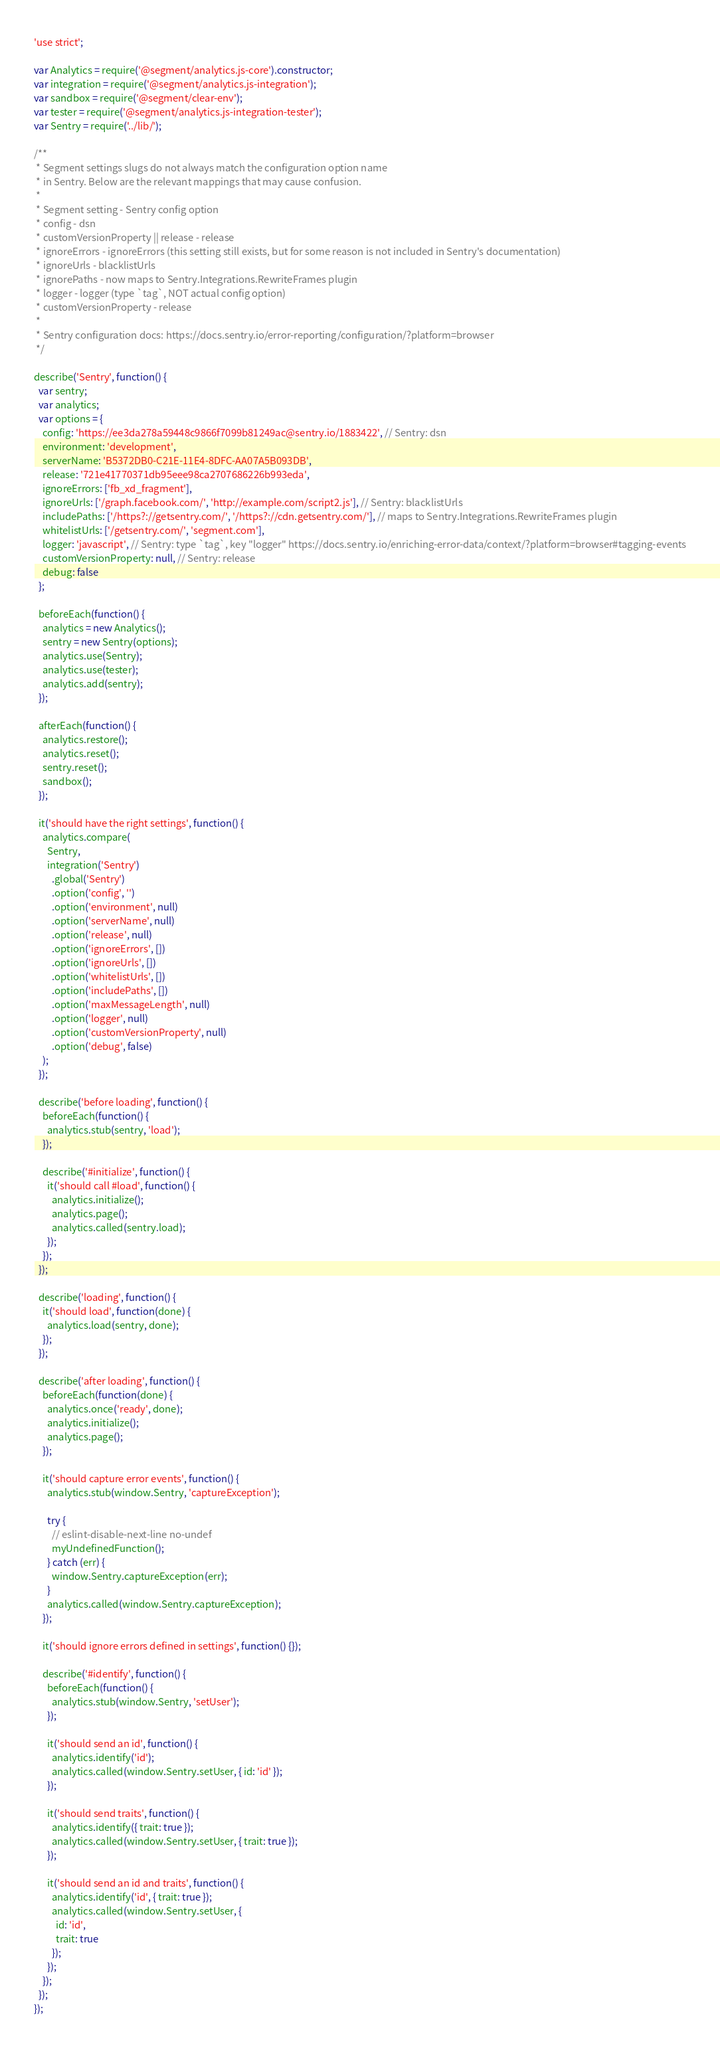<code> <loc_0><loc_0><loc_500><loc_500><_JavaScript_>'use strict';

var Analytics = require('@segment/analytics.js-core').constructor;
var integration = require('@segment/analytics.js-integration');
var sandbox = require('@segment/clear-env');
var tester = require('@segment/analytics.js-integration-tester');
var Sentry = require('../lib/');

/**
 * Segment settings slugs do not always match the configuration option name
 * in Sentry. Below are the relevant mappings that may cause confusion.
 *
 * Segment setting - Sentry config option
 * config - dsn
 * customVersionProperty || release - release
 * ignoreErrors - ignoreErrors (this setting still exists, but for some reason is not included in Sentry's documentation)
 * ignoreUrls - blacklistUrls
 * ignorePaths - now maps to Sentry.Integrations.RewriteFrames plugin
 * logger - logger (type `tag`, NOT actual config option)
 * customVersionProperty - release
 *
 * Sentry configuration docs: https://docs.sentry.io/error-reporting/configuration/?platform=browser
 */

describe('Sentry', function() {
  var sentry;
  var analytics;
  var options = {
    config: 'https://ee3da278a59448c9866f7099b81249ac@sentry.io/1883422', // Sentry: dsn
    environment: 'development',
    serverName: 'B5372DB0-C21E-11E4-8DFC-AA07A5B093DB',
    release: '721e41770371db95eee98ca2707686226b993eda',
    ignoreErrors: ['fb_xd_fragment'],
    ignoreUrls: ['/graph.facebook.com/', 'http://example.com/script2.js'], // Sentry: blacklistUrls
    includePaths: ['/https?://getsentry.com/', '/https?://cdn.getsentry.com/'], // maps to Sentry.Integrations.RewriteFrames plugin
    whitelistUrls: ['/getsentry.com/', 'segment.com'],
    logger: 'javascript', // Sentry: type `tag`, key "logger" https://docs.sentry.io/enriching-error-data/context/?platform=browser#tagging-events
    customVersionProperty: null, // Sentry: release
    debug: false
  };

  beforeEach(function() {
    analytics = new Analytics();
    sentry = new Sentry(options);
    analytics.use(Sentry);
    analytics.use(tester);
    analytics.add(sentry);
  });

  afterEach(function() {
    analytics.restore();
    analytics.reset();
    sentry.reset();
    sandbox();
  });

  it('should have the right settings', function() {
    analytics.compare(
      Sentry,
      integration('Sentry')
        .global('Sentry')
        .option('config', '')
        .option('environment', null)
        .option('serverName', null)
        .option('release', null)
        .option('ignoreErrors', [])
        .option('ignoreUrls', [])
        .option('whitelistUrls', [])
        .option('includePaths', [])
        .option('maxMessageLength', null)
        .option('logger', null)
        .option('customVersionProperty', null)
        .option('debug', false)
    );
  });

  describe('before loading', function() {
    beforeEach(function() {
      analytics.stub(sentry, 'load');
    });

    describe('#initialize', function() {
      it('should call #load', function() {
        analytics.initialize();
        analytics.page();
        analytics.called(sentry.load);
      });
    });
  });

  describe('loading', function() {
    it('should load', function(done) {
      analytics.load(sentry, done);
    });
  });

  describe('after loading', function() {
    beforeEach(function(done) {
      analytics.once('ready', done);
      analytics.initialize();
      analytics.page();
    });

    it('should capture error events', function() {
      analytics.stub(window.Sentry, 'captureException');

      try {
        // eslint-disable-next-line no-undef
        myUndefinedFunction();
      } catch (err) {
        window.Sentry.captureException(err);
      }
      analytics.called(window.Sentry.captureException);
    });

    it('should ignore errors defined in settings', function() {});

    describe('#identify', function() {
      beforeEach(function() {
        analytics.stub(window.Sentry, 'setUser');
      });

      it('should send an id', function() {
        analytics.identify('id');
        analytics.called(window.Sentry.setUser, { id: 'id' });
      });

      it('should send traits', function() {
        analytics.identify({ trait: true });
        analytics.called(window.Sentry.setUser, { trait: true });
      });

      it('should send an id and traits', function() {
        analytics.identify('id', { trait: true });
        analytics.called(window.Sentry.setUser, {
          id: 'id',
          trait: true
        });
      });
    });
  });
});
</code> 